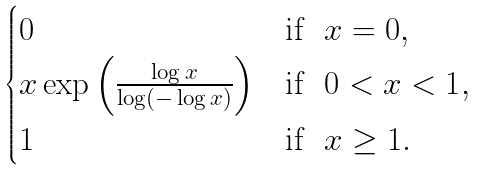<formula> <loc_0><loc_0><loc_500><loc_500>\begin{cases} 0 & \text {if \ $x = 0$} , \\ x \exp \left ( \frac { \log x } { \log ( - \log x ) } \right ) & \text {if \ $0 < x < 1$} , \\ 1 & \text {if \ $x \geq 1$} . \end{cases}</formula> 